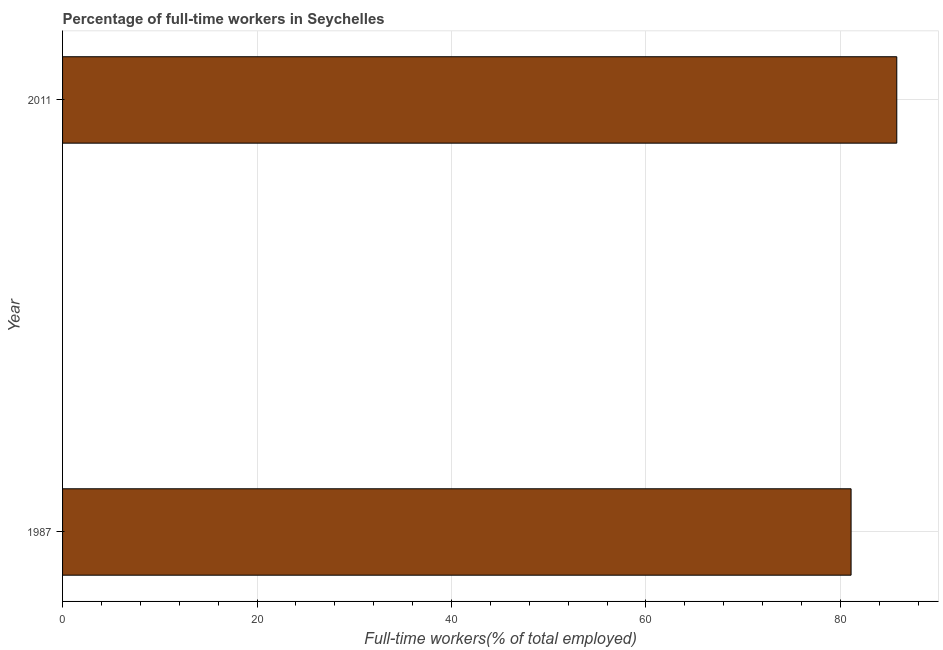Does the graph contain any zero values?
Give a very brief answer. No. What is the title of the graph?
Make the answer very short. Percentage of full-time workers in Seychelles. What is the label or title of the X-axis?
Provide a succinct answer. Full-time workers(% of total employed). What is the percentage of full-time workers in 1987?
Offer a very short reply. 81.1. Across all years, what is the maximum percentage of full-time workers?
Make the answer very short. 85.8. Across all years, what is the minimum percentage of full-time workers?
Offer a terse response. 81.1. In which year was the percentage of full-time workers maximum?
Keep it short and to the point. 2011. In which year was the percentage of full-time workers minimum?
Your answer should be compact. 1987. What is the sum of the percentage of full-time workers?
Provide a succinct answer. 166.9. What is the difference between the percentage of full-time workers in 1987 and 2011?
Give a very brief answer. -4.7. What is the average percentage of full-time workers per year?
Your answer should be compact. 83.45. What is the median percentage of full-time workers?
Offer a very short reply. 83.45. In how many years, is the percentage of full-time workers greater than 80 %?
Offer a terse response. 2. What is the ratio of the percentage of full-time workers in 1987 to that in 2011?
Ensure brevity in your answer.  0.94. Is the percentage of full-time workers in 1987 less than that in 2011?
Offer a very short reply. Yes. How many bars are there?
Ensure brevity in your answer.  2. Are all the bars in the graph horizontal?
Your answer should be very brief. Yes. How many years are there in the graph?
Ensure brevity in your answer.  2. What is the Full-time workers(% of total employed) of 1987?
Provide a short and direct response. 81.1. What is the Full-time workers(% of total employed) in 2011?
Provide a short and direct response. 85.8. What is the ratio of the Full-time workers(% of total employed) in 1987 to that in 2011?
Provide a short and direct response. 0.94. 